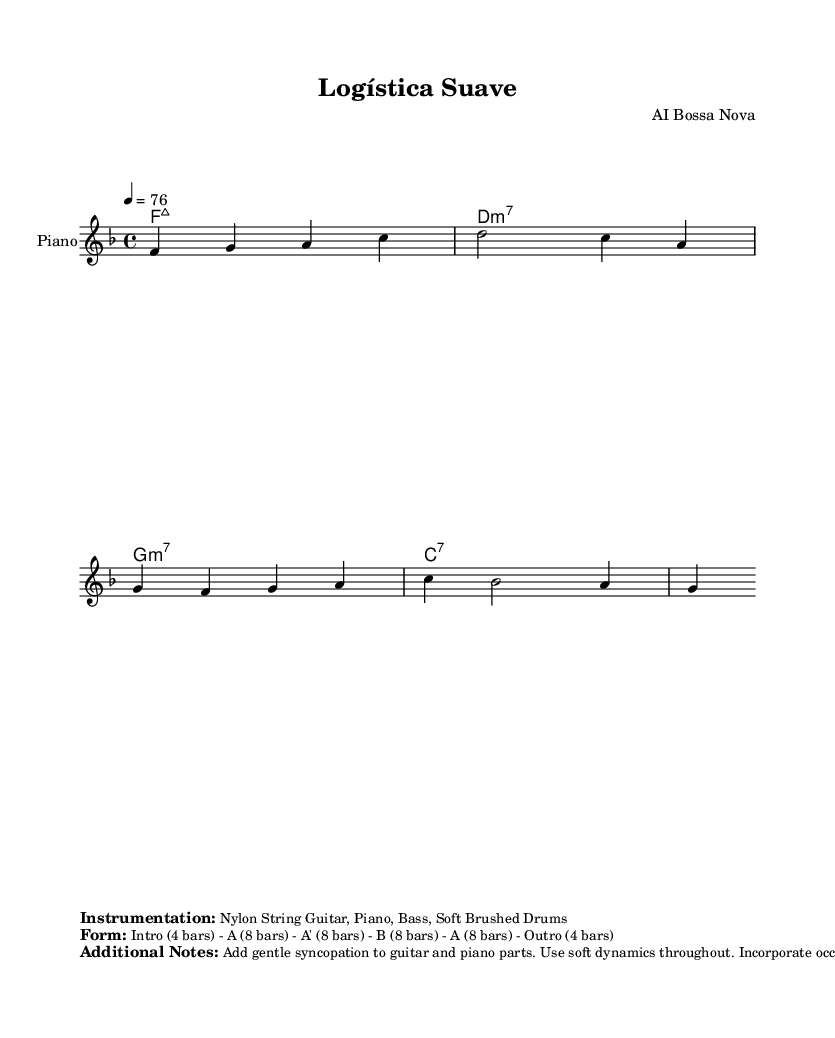What is the key signature of this music? The key signature is F major, which has one flat (B flat). This can be identified by looking at the clef at the beginning of the staff where the flats are indicated.
Answer: F major What is the time signature of this music? The time signature is 4/4, as indicated at the beginning of the score. This means there are four beats in each measure, and the quarter note receives one beat.
Answer: 4/4 What is the tempo marking for this piece? The tempo marking is 76, found at the top of the score, defining the beats per minute for the performance.
Answer: 76 How many measures are in the A section of the form? The A section consists of 8 measures, as shown in the form description. The structure indicates that the A section is repeated once.
Answer: 8 measures Which instrument is primarily indicated for the melody? The primary instrument indicated for the melody is the Piano, which is noted at the start of the staff along with the instrument name.
Answer: Piano What type of chord is used in the first bar? The first bar contains an F major 7 chord, as seen in the chord names above the staff. This chord is composed of the root, third, fifth, and the seventh degree of the F major scale.
Answer: F:maj7 How should the dynamics be throughout the piece? The dynamics should be soft, as specified in the additional notes section of the sheet music, indicating a gentle playing style.
Answer: Soft 